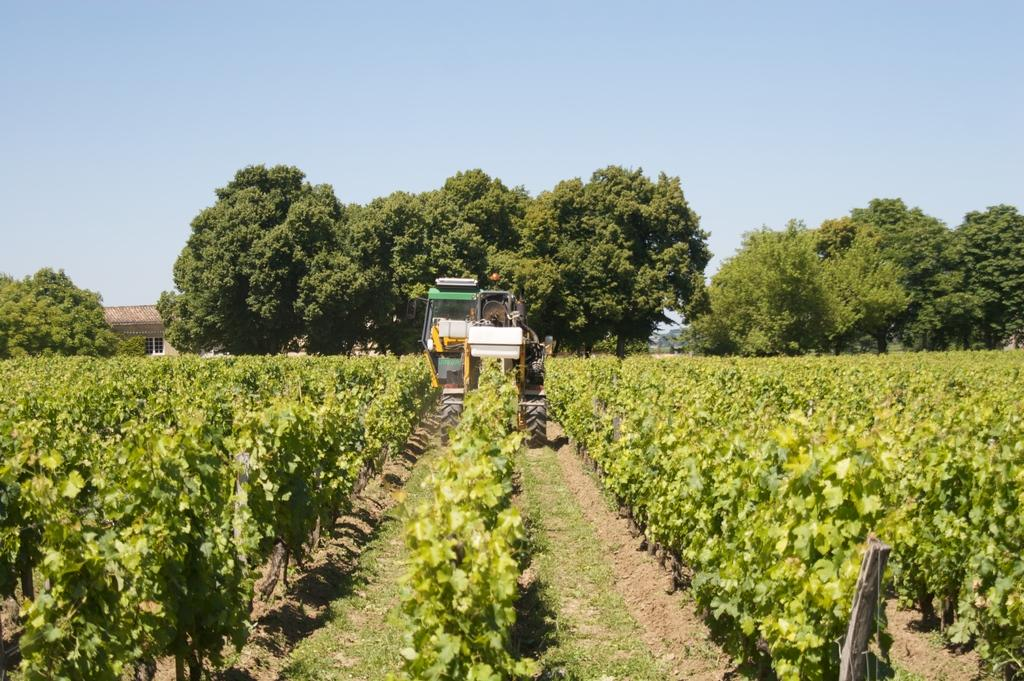What type of plants can be seen in the image? There are many crops in the image. Is there any machinery or equipment visible among the crops? Yes, there is a vehicle among the crops. What can be seen in the distance behind the crops? There are plenty of trees and a house in the background of the image. What type of mint is growing among the crops in the image? There is no mint mentioned or visible in the image; it only features crops, a vehicle, trees, and a house. 